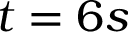Convert formula to latex. <formula><loc_0><loc_0><loc_500><loc_500>t = 6 s</formula> 